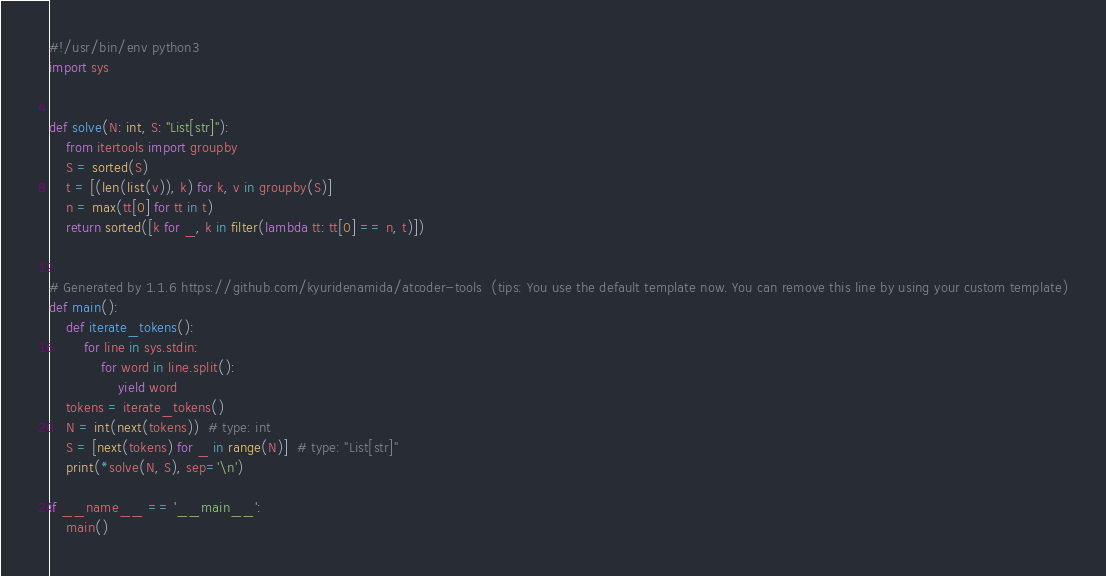<code> <loc_0><loc_0><loc_500><loc_500><_Python_>#!/usr/bin/env python3
import sys


def solve(N: int, S: "List[str]"):
    from itertools import groupby
    S = sorted(S)
    t = [(len(list(v)), k) for k, v in groupby(S)]
    n = max(tt[0] for tt in t)
    return sorted([k for _, k in filter(lambda tt: tt[0] == n, t)])


# Generated by 1.1.6 https://github.com/kyuridenamida/atcoder-tools  (tips: You use the default template now. You can remove this line by using your custom template)
def main():
    def iterate_tokens():
        for line in sys.stdin:
            for word in line.split():
                yield word
    tokens = iterate_tokens()
    N = int(next(tokens))  # type: int
    S = [next(tokens) for _ in range(N)]  # type: "List[str]"
    print(*solve(N, S), sep='\n')

if __name__ == '__main__':
    main()
</code> 